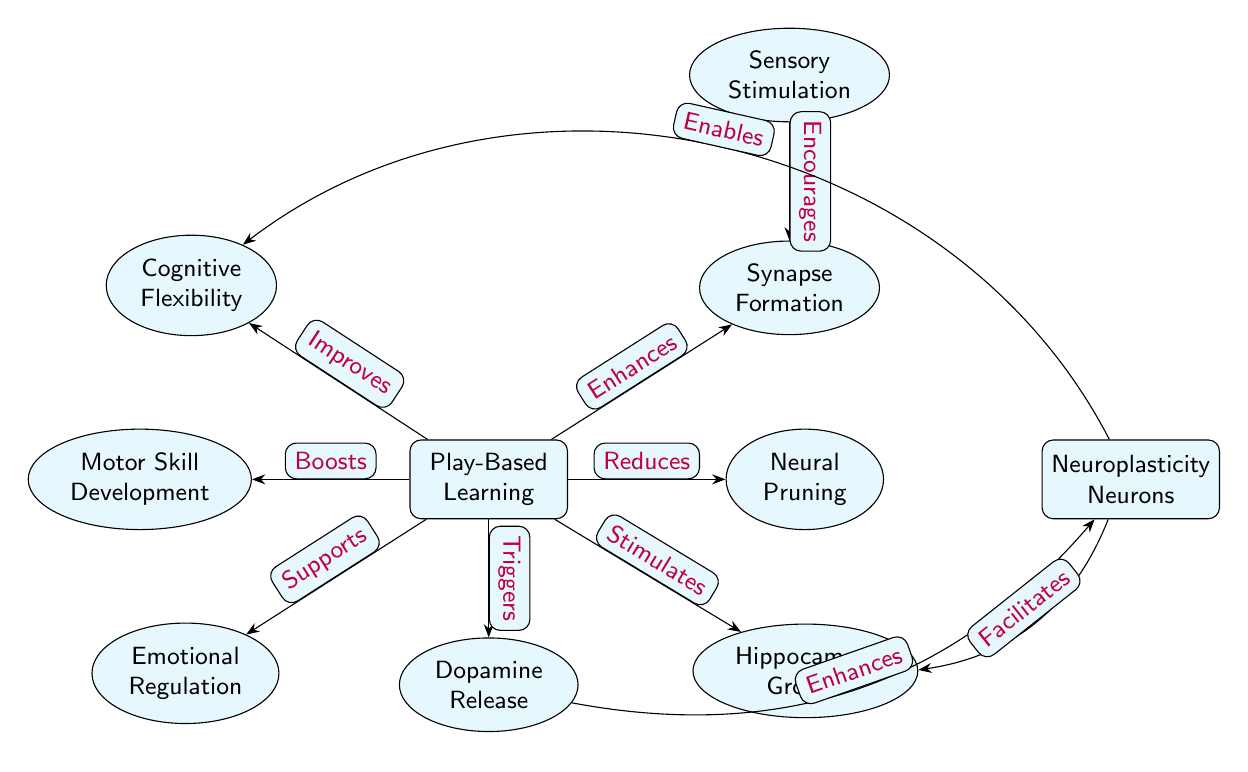What is the main node in the diagram? The main node is labeled "Play-Based Learning," which is positioned centrally in the diagram and connects to various secondary nodes.
Answer: Play-Based Learning How many secondary nodes are present in the diagram? By counting the nodes labeled as secondary, we find a total of six secondary nodes connected to the main node, "Play-Based Learning."
Answer: 6 Which node does play-based learning enhance? The edge labeled "Enhances" from the main node points to the "Synapse Formation" node, indicating the enhancement relationship between them.
Answer: Synapse Formation What does dopamine release stimulate according to the diagram? Following the edge labeled "Triggers" from the "Play-Based Learning" node to the "Dopamine Release" node, we see that the dopamine release then enhances the "Neuroplasticity Neurons" node.
Answer: Neuroplasticity Neurons How does sensory stimulation interact with synapse formation? The edge from the "Sensory Stimulation" node to the "Synapse Formation" node is labeled "Encourages," indicating that sensory stimulation encourages the formation of synapses.
Answer: Encourages Which relationship indicates that play-based learning reduces neural pruning? There is a direct edge between "Play-Based Learning" and "Neural Pruning" labeled "Reduces," which clearly defines this relationship.
Answer: Reduces What are the two processes facilitated by neuroplasticity neurons? The edges from the "Neuroplasticity Neurons" node indicate that neuroplasticity facilitates “Hippocampal Growth” and “Cognitive Flexibility.” Both are connected by directed edges from the neuroplasticity neurons.
Answer: Hippocampal Growth, Cognitive Flexibility How many connections spread from the main node "Play-Based Learning"? The main node is connected to seven different nodes, which shows the various developmental processes influenced by play-based learning.
Answer: 7 What aspect does play-based learning support related to emotional health? The edge labeled "Supports" from the "Play-Based Learning" node directs towards "Emotional Regulation," illustrating the supportive relationship.
Answer: Emotional Regulation Which node improves cognitive flexibility directly according to the diagram? The direct edge labeled "Improves" from the "Play-Based Learning" node points towards "Cognitive Flexibility," indicating a clear improvement.
Answer: Cognitive Flexibility 